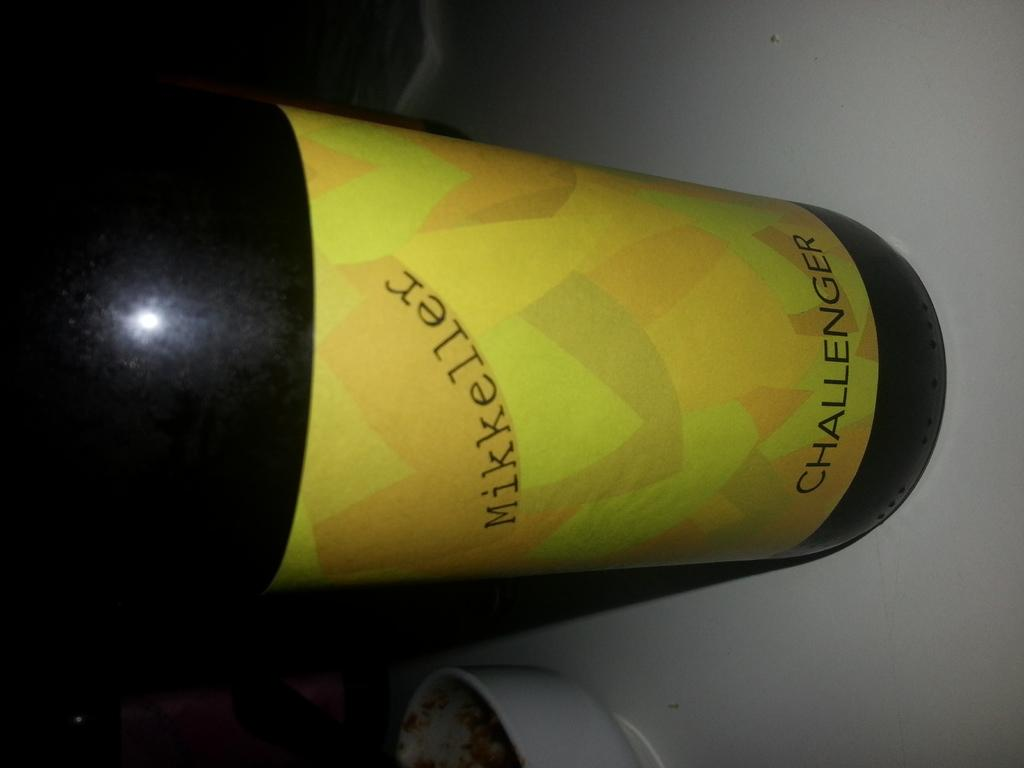<image>
Summarize the visual content of the image. A bottle of Mikkeller Challenger wine sitting on a table. 